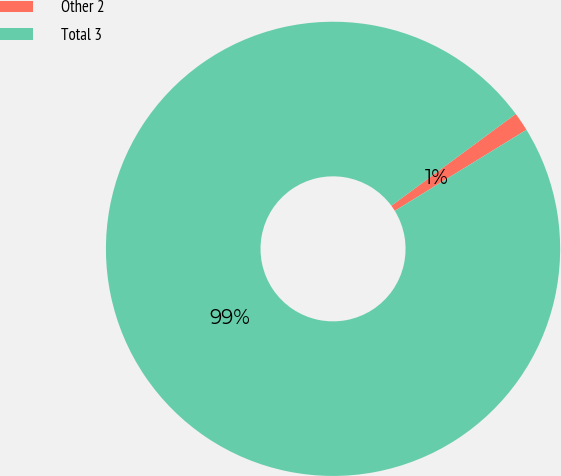Convert chart to OTSL. <chart><loc_0><loc_0><loc_500><loc_500><pie_chart><fcel>Other 2<fcel>Total 3<nl><fcel>1.34%<fcel>98.66%<nl></chart> 